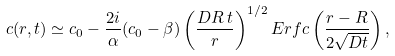Convert formula to latex. <formula><loc_0><loc_0><loc_500><loc_500>c ( r , t ) \simeq c _ { 0 } - \frac { 2 i } { \alpha } ( c _ { 0 } - \beta ) \left ( \frac { D R \, t } { r } \right ) ^ { 1 / 2 } E r f c \left ( \frac { r - R } { 2 \sqrt { D t } } \right ) ,</formula> 